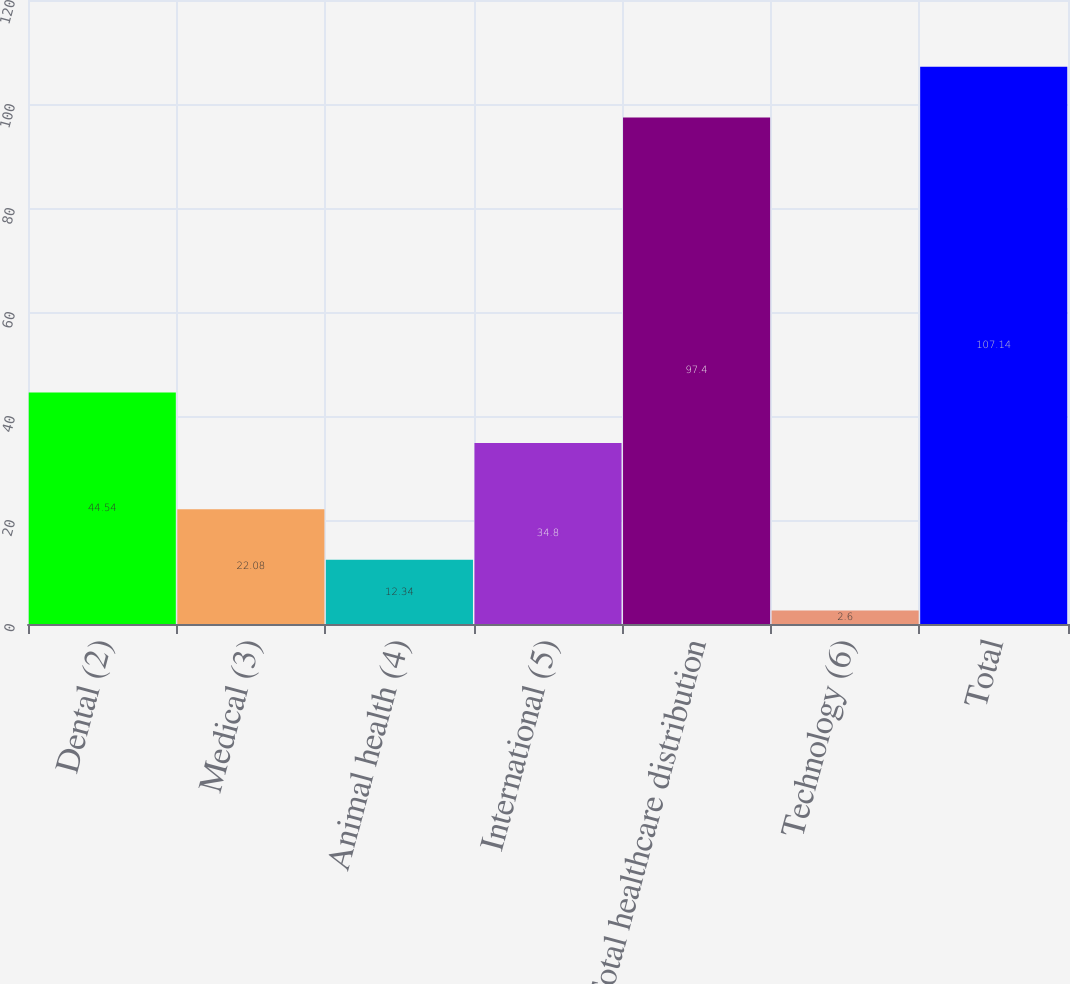Convert chart. <chart><loc_0><loc_0><loc_500><loc_500><bar_chart><fcel>Dental (2)<fcel>Medical (3)<fcel>Animal health (4)<fcel>International (5)<fcel>Total healthcare distribution<fcel>Technology (6)<fcel>Total<nl><fcel>44.54<fcel>22.08<fcel>12.34<fcel>34.8<fcel>97.4<fcel>2.6<fcel>107.14<nl></chart> 